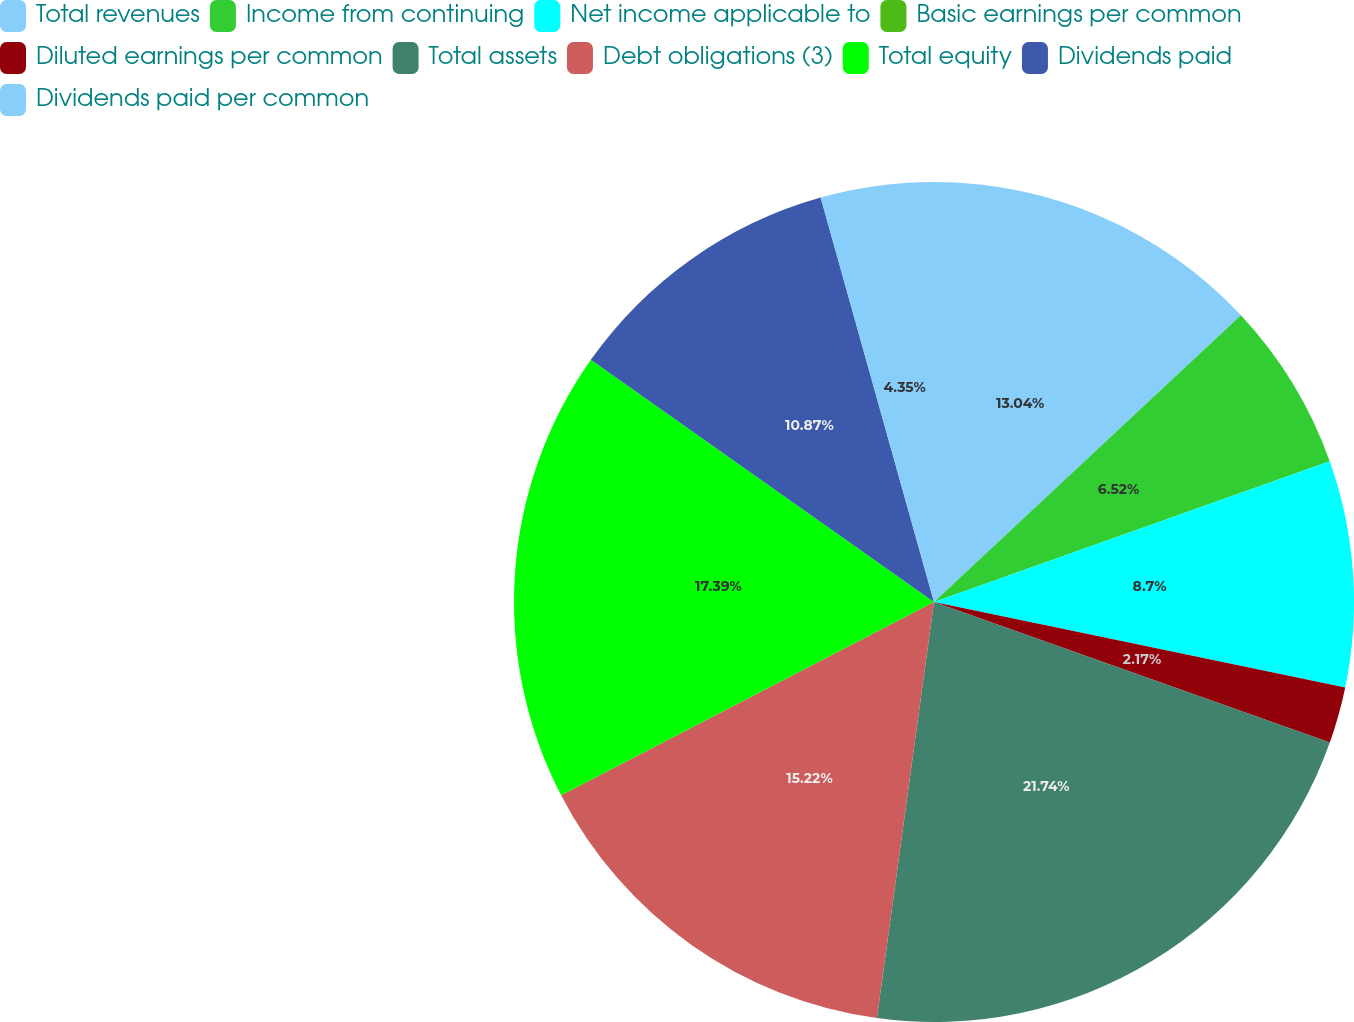Convert chart. <chart><loc_0><loc_0><loc_500><loc_500><pie_chart><fcel>Total revenues<fcel>Income from continuing<fcel>Net income applicable to<fcel>Basic earnings per common<fcel>Diluted earnings per common<fcel>Total assets<fcel>Debt obligations (3)<fcel>Total equity<fcel>Dividends paid<fcel>Dividends paid per common<nl><fcel>13.04%<fcel>6.52%<fcel>8.7%<fcel>0.0%<fcel>2.17%<fcel>21.74%<fcel>15.22%<fcel>17.39%<fcel>10.87%<fcel>4.35%<nl></chart> 